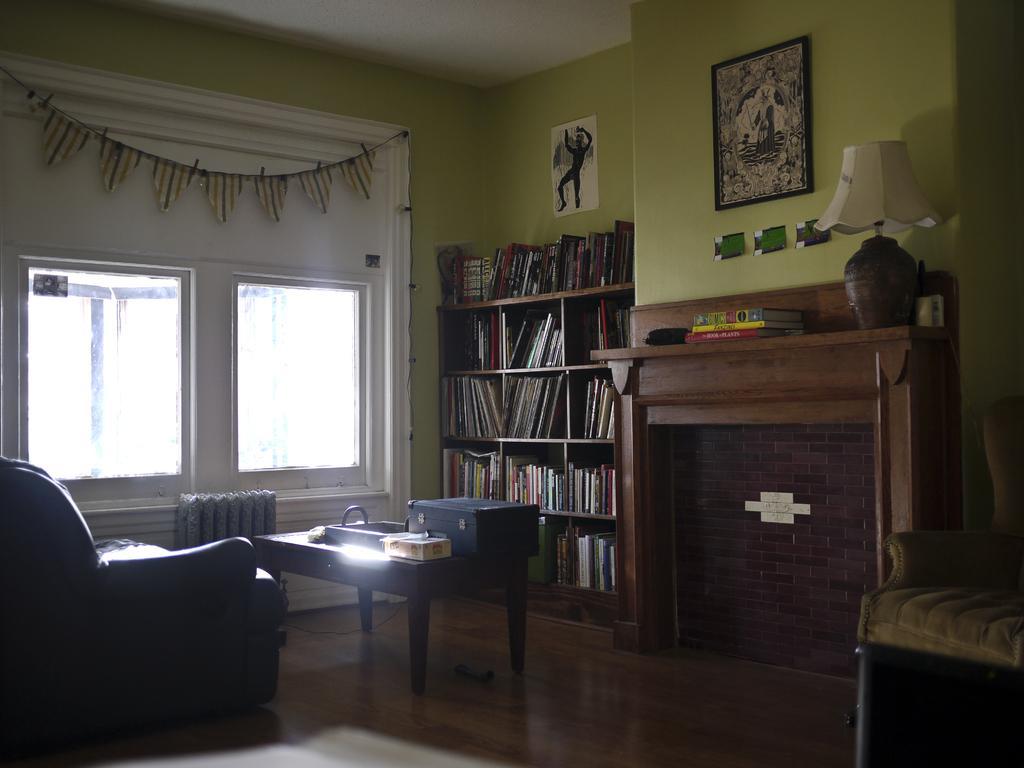Describe this image in one or two sentences. There is a black sofa in left corner and a bookshelf in the right corner and there is a table in between them, In background there is a window and the wall is green in color. 